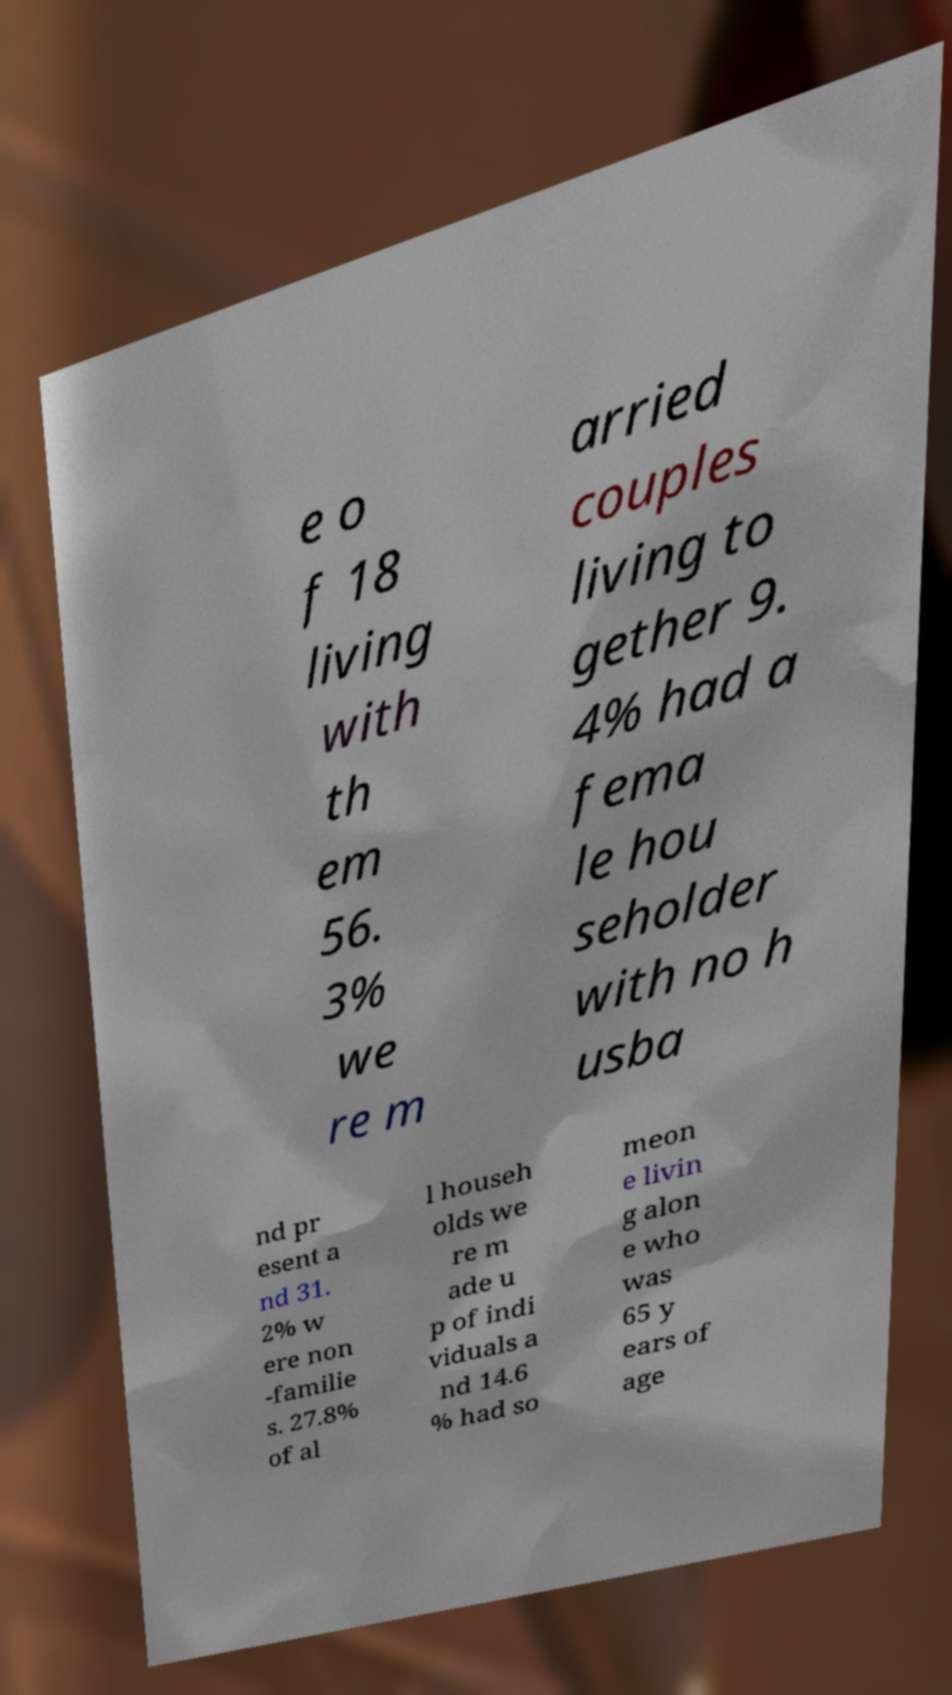For documentation purposes, I need the text within this image transcribed. Could you provide that? e o f 18 living with th em 56. 3% we re m arried couples living to gether 9. 4% had a fema le hou seholder with no h usba nd pr esent a nd 31. 2% w ere non -familie s. 27.8% of al l househ olds we re m ade u p of indi viduals a nd 14.6 % had so meon e livin g alon e who was 65 y ears of age 